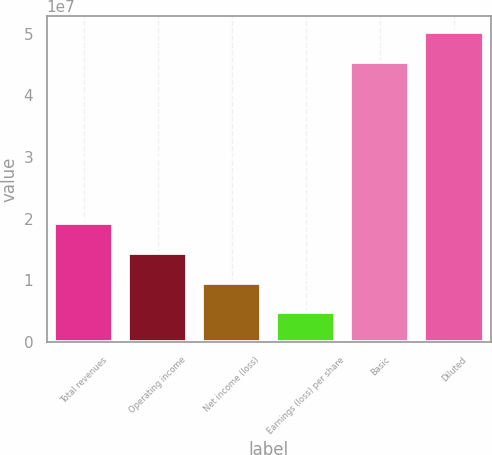<chart> <loc_0><loc_0><loc_500><loc_500><bar_chart><fcel>Total revenues<fcel>Operating income<fcel>Net income (loss)<fcel>Earnings (loss) per share<fcel>Basic<fcel>Diluted<nl><fcel>1.92248e+07<fcel>1.44186e+07<fcel>9.61242e+06<fcel>4.80621e+06<fcel>4.54769e+07<fcel>5.02831e+07<nl></chart> 